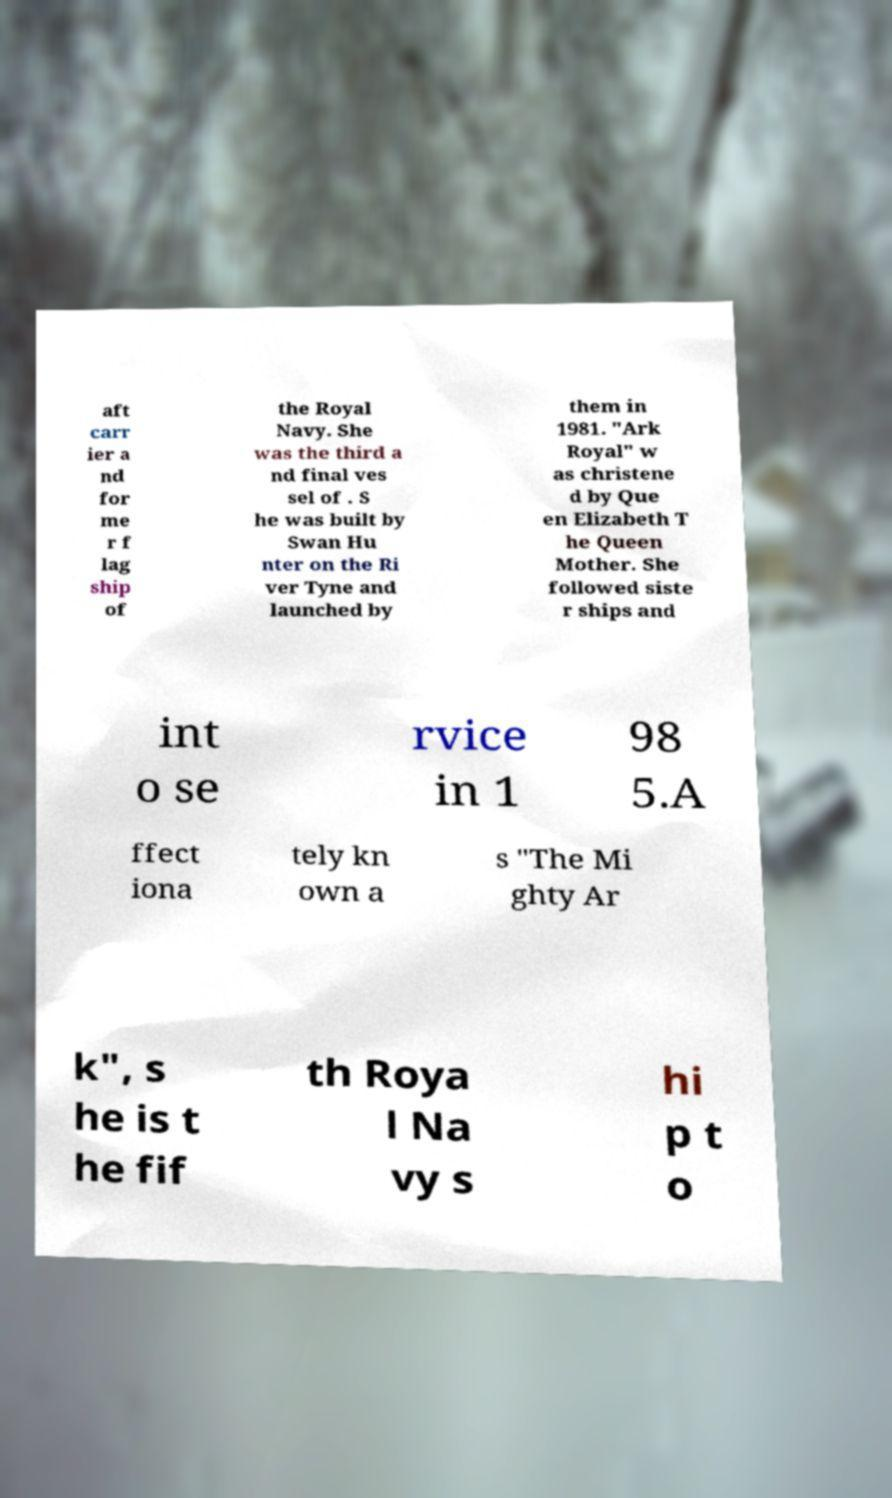Please identify and transcribe the text found in this image. aft carr ier a nd for me r f lag ship of the Royal Navy. She was the third a nd final ves sel of . S he was built by Swan Hu nter on the Ri ver Tyne and launched by them in 1981. "Ark Royal" w as christene d by Que en Elizabeth T he Queen Mother. She followed siste r ships and int o se rvice in 1 98 5.A ffect iona tely kn own a s "The Mi ghty Ar k", s he is t he fif th Roya l Na vy s hi p t o 